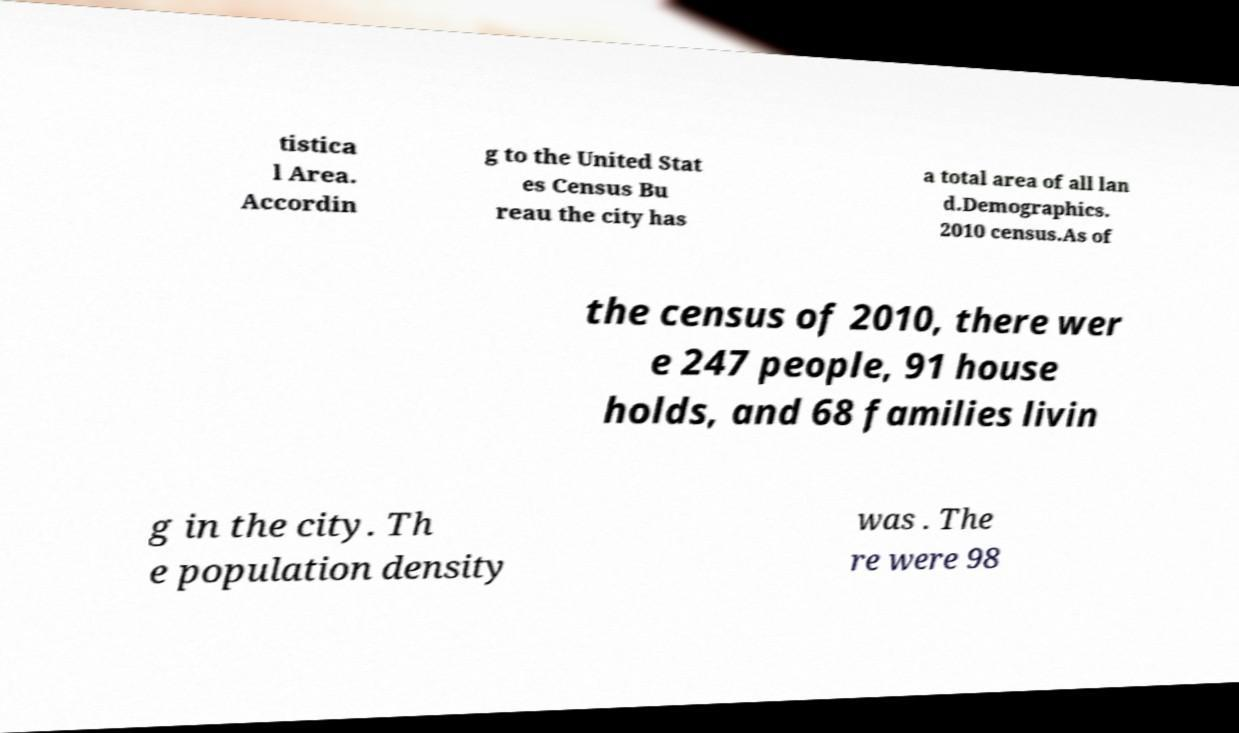Please read and relay the text visible in this image. What does it say? tistica l Area. Accordin g to the United Stat es Census Bu reau the city has a total area of all lan d.Demographics. 2010 census.As of the census of 2010, there wer e 247 people, 91 house holds, and 68 families livin g in the city. Th e population density was . The re were 98 